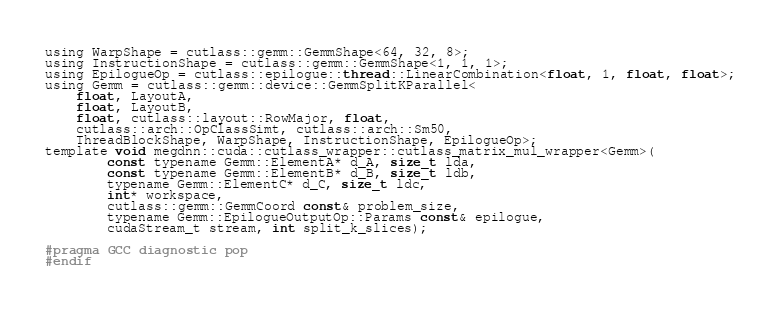Convert code to text. <code><loc_0><loc_0><loc_500><loc_500><_Cuda_>using WarpShape = cutlass::gemm::GemmShape<64, 32, 8>;
using InstructionShape = cutlass::gemm::GemmShape<1, 1, 1>;
using EpilogueOp = cutlass::epilogue::thread::LinearCombination<float, 1, float, float>;
using Gemm = cutlass::gemm::device::GemmSplitKParallel<
    float, LayoutA, 
    float, LayoutB, 
    float, cutlass::layout::RowMajor, float, 
    cutlass::arch::OpClassSimt, cutlass::arch::Sm50, 
    ThreadBlockShape, WarpShape, InstructionShape, EpilogueOp>;
template void megdnn::cuda::cutlass_wrapper::cutlass_matrix_mul_wrapper<Gemm>(
        const typename Gemm::ElementA* d_A, size_t lda, 
        const typename Gemm::ElementB* d_B, size_t ldb,  
        typename Gemm::ElementC* d_C, size_t ldc,  
        int* workspace, 
        cutlass::gemm::GemmCoord const& problem_size,   
        typename Gemm::EpilogueOutputOp::Params const& epilogue, 
        cudaStream_t stream, int split_k_slices);

#pragma GCC diagnostic pop
#endif
</code> 